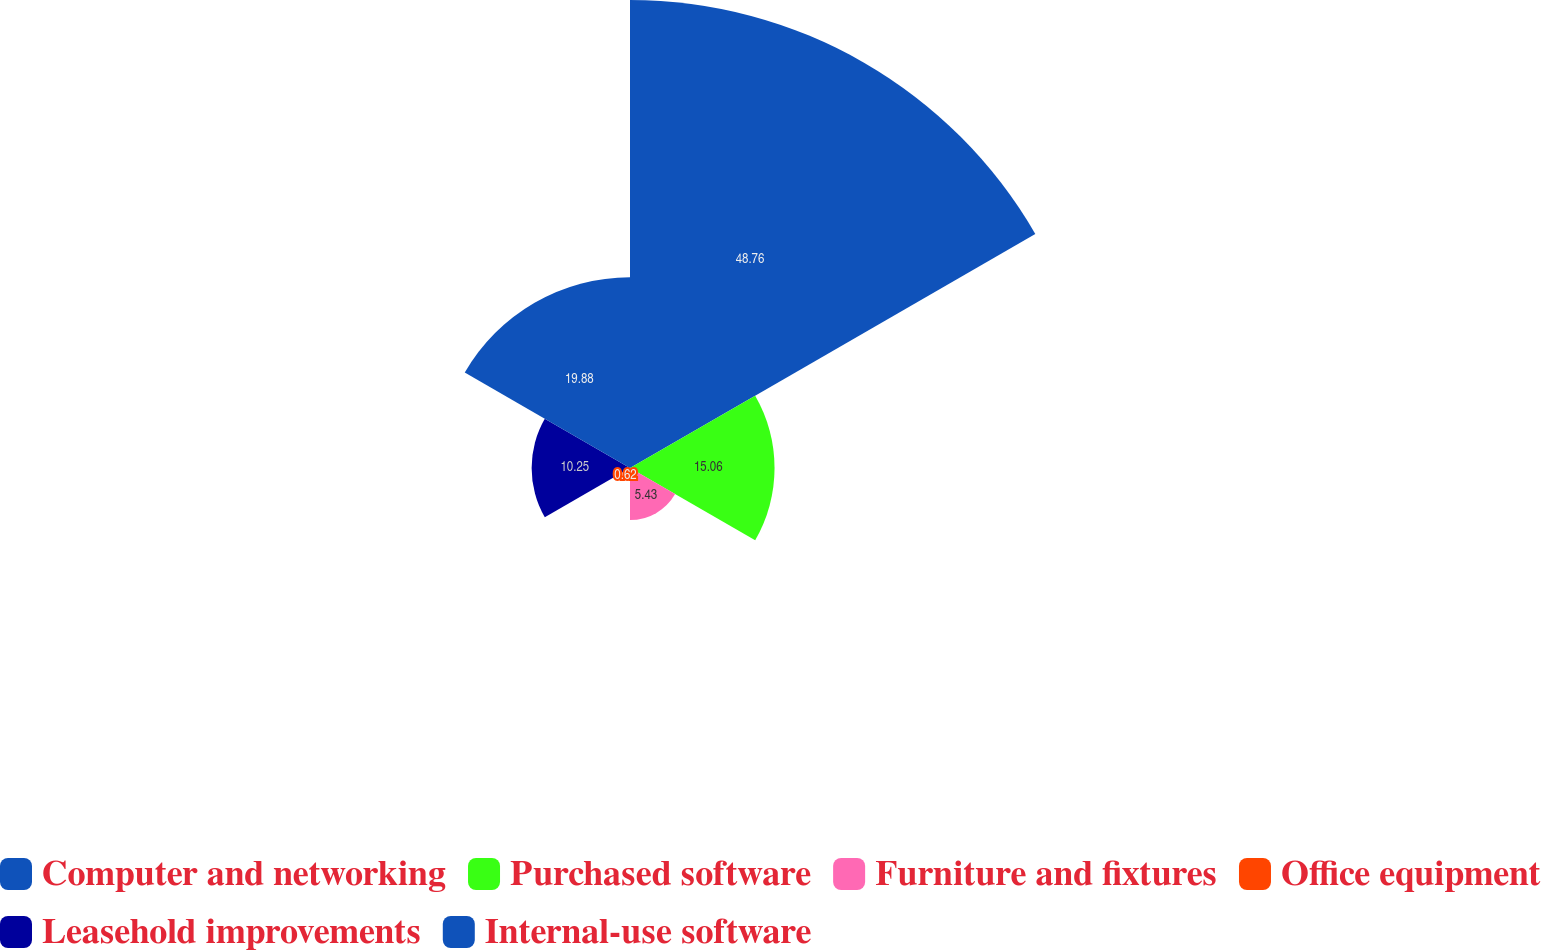<chart> <loc_0><loc_0><loc_500><loc_500><pie_chart><fcel>Computer and networking<fcel>Purchased software<fcel>Furniture and fixtures<fcel>Office equipment<fcel>Leasehold improvements<fcel>Internal-use software<nl><fcel>48.76%<fcel>15.06%<fcel>5.43%<fcel>0.62%<fcel>10.25%<fcel>19.88%<nl></chart> 